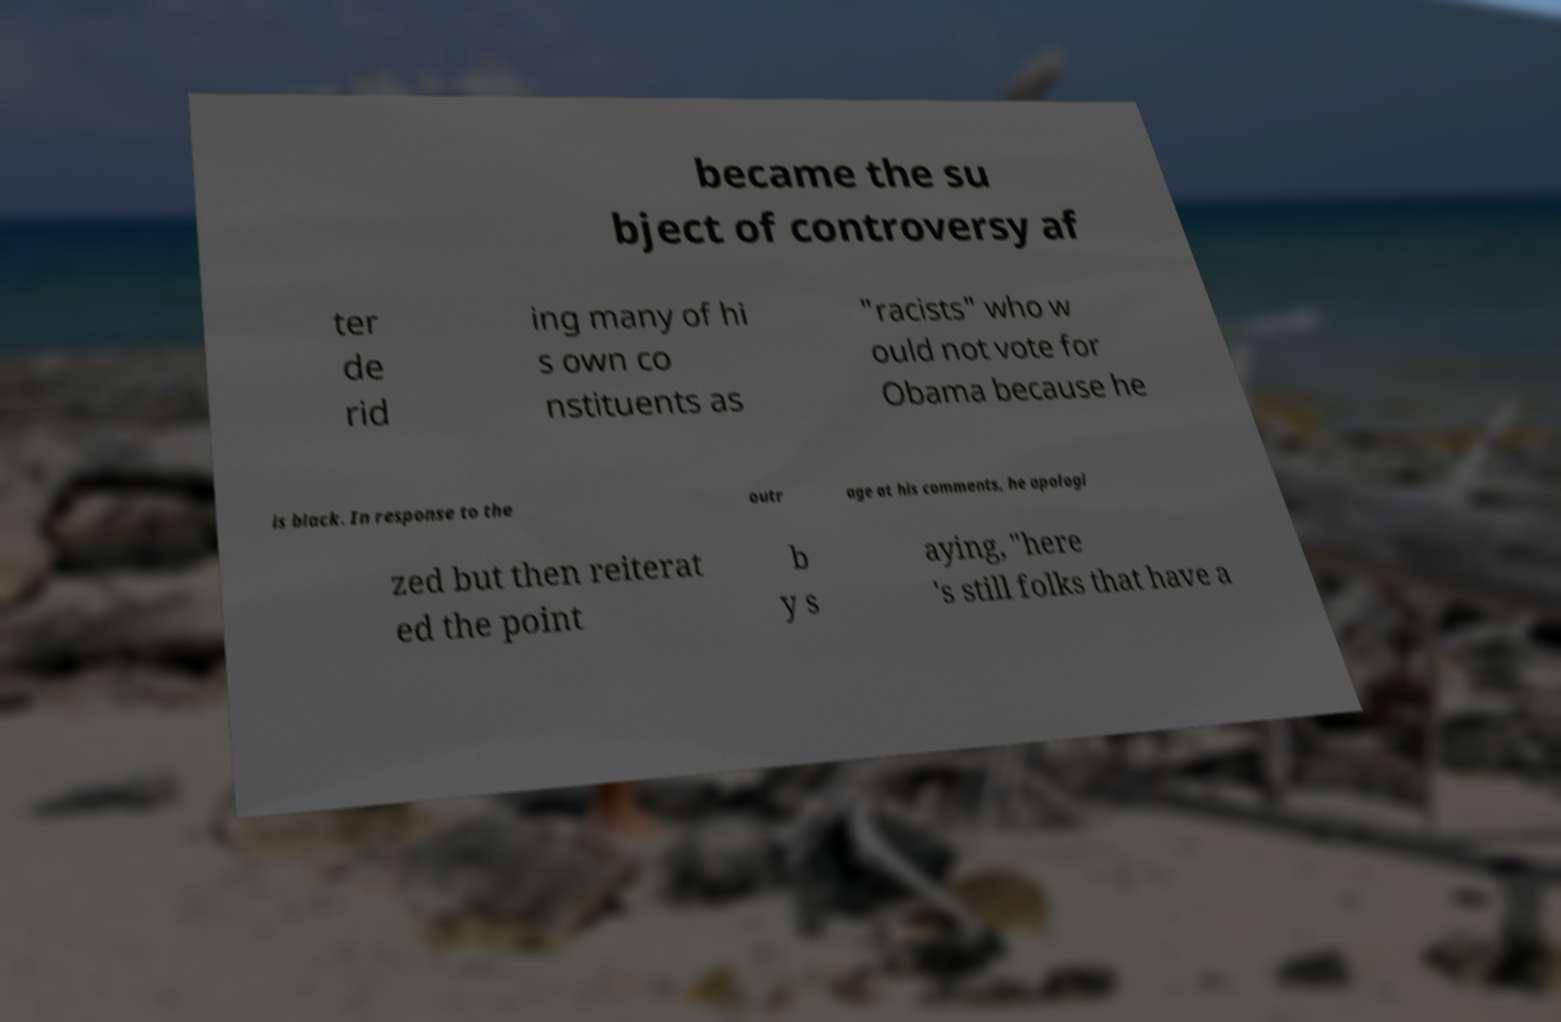Please identify and transcribe the text found in this image. became the su bject of controversy af ter de rid ing many of hi s own co nstituents as "racists" who w ould not vote for Obama because he is black. In response to the outr age at his comments, he apologi zed but then reiterat ed the point b y s aying, "here 's still folks that have a 